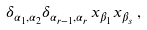Convert formula to latex. <formula><loc_0><loc_0><loc_500><loc_500>\delta _ { \alpha _ { 1 } , \alpha _ { 2 } } \delta _ { \alpha _ { r - 1 } , \alpha _ { r } } \, x _ { \beta _ { 1 } } x _ { \beta _ { s } } \, ,</formula> 